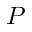Convert formula to latex. <formula><loc_0><loc_0><loc_500><loc_500>P</formula> 